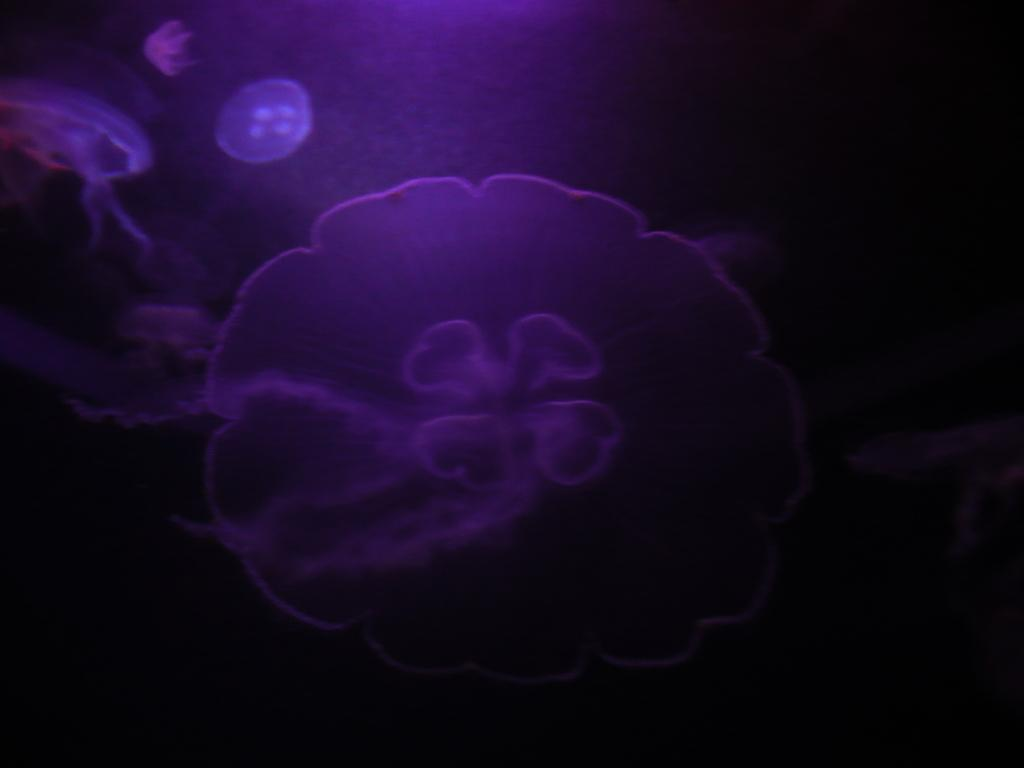What is the main subject in the center of the image? There are jellyfishes in the center of the image. What type of calculator can be seen in the image? There is no calculator present in the image; it features jellyfishes in the center. 